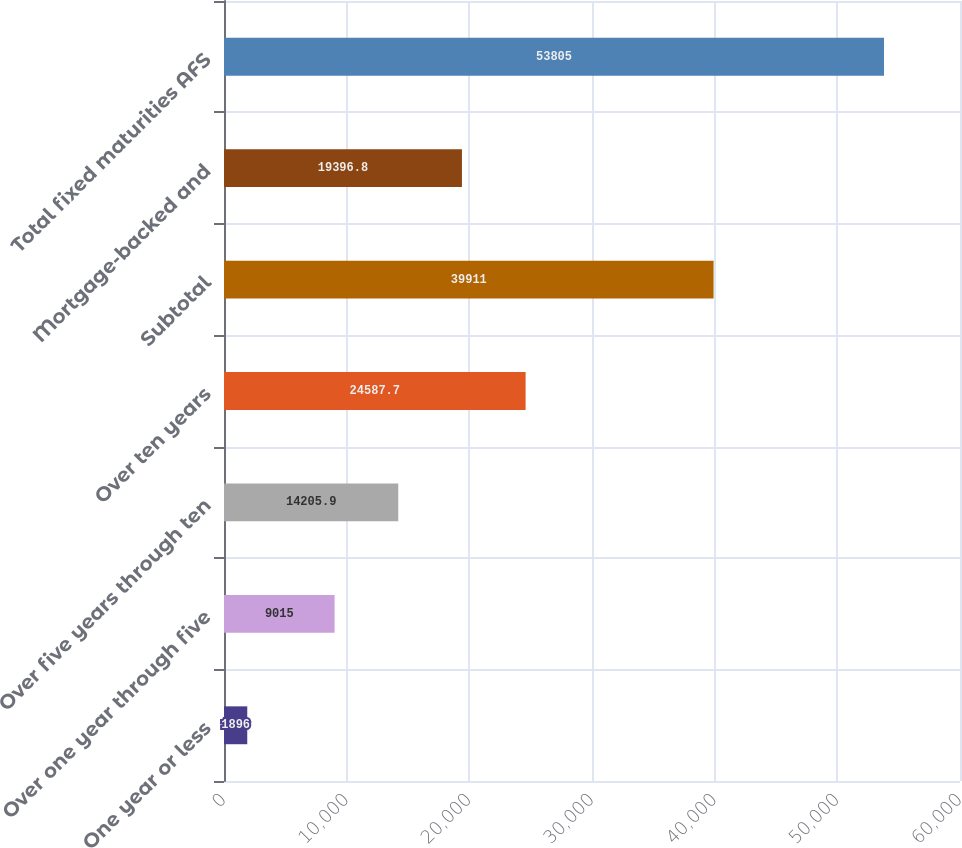Convert chart. <chart><loc_0><loc_0><loc_500><loc_500><bar_chart><fcel>One year or less<fcel>Over one year through five<fcel>Over five years through ten<fcel>Over ten years<fcel>Subtotal<fcel>Mortgage-backed and<fcel>Total fixed maturities AFS<nl><fcel>1896<fcel>9015<fcel>14205.9<fcel>24587.7<fcel>39911<fcel>19396.8<fcel>53805<nl></chart> 